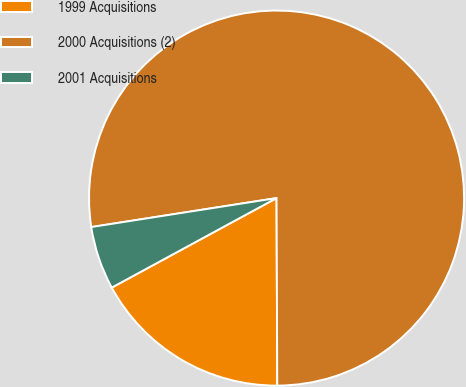Convert chart. <chart><loc_0><loc_0><loc_500><loc_500><pie_chart><fcel>1999 Acquisitions<fcel>2000 Acquisitions (2)<fcel>2001 Acquisitions<nl><fcel>17.14%<fcel>77.41%<fcel>5.45%<nl></chart> 